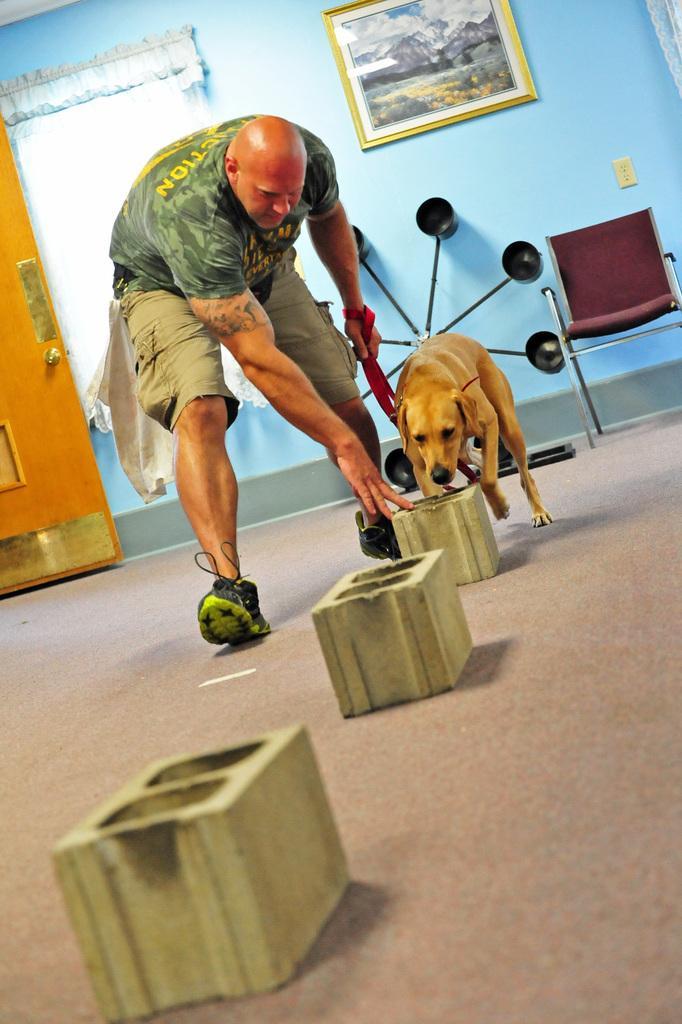Please provide a concise description of this image. In this picture we have a man and dog. 